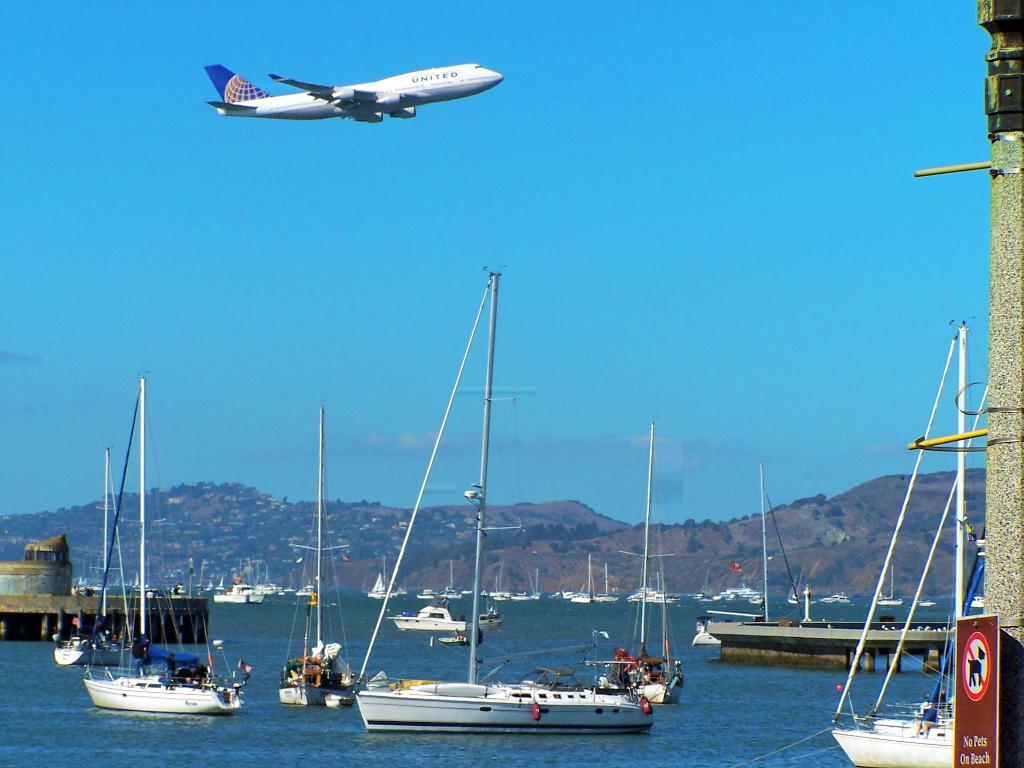What does the red sign in front of the harbor say?
Offer a very short reply. No pets on beach. What airline is the plane from?
Your response must be concise. United. 